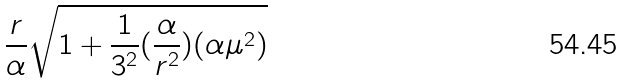<formula> <loc_0><loc_0><loc_500><loc_500>\frac { r } { \alpha } \sqrt { 1 + \frac { 1 } { 3 ^ { 2 } } ( \frac { \alpha } { r ^ { 2 } } ) ( \alpha \mu ^ { 2 } ) }</formula> 